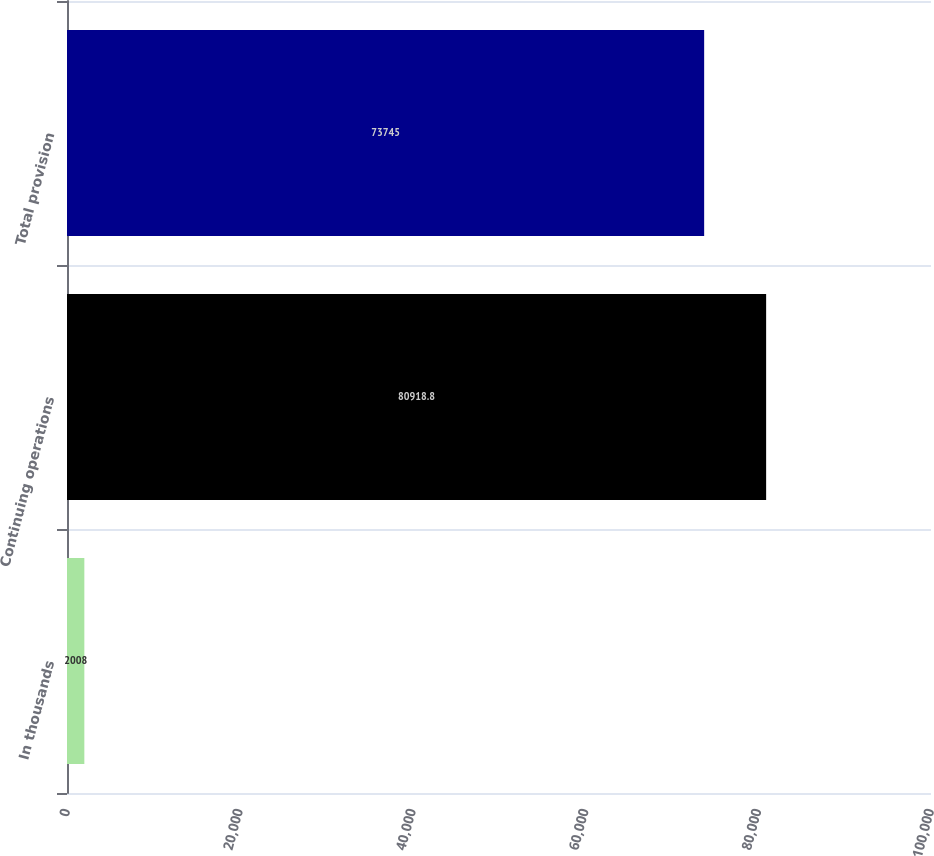Convert chart to OTSL. <chart><loc_0><loc_0><loc_500><loc_500><bar_chart><fcel>In thousands<fcel>Continuing operations<fcel>Total provision<nl><fcel>2008<fcel>80918.8<fcel>73745<nl></chart> 